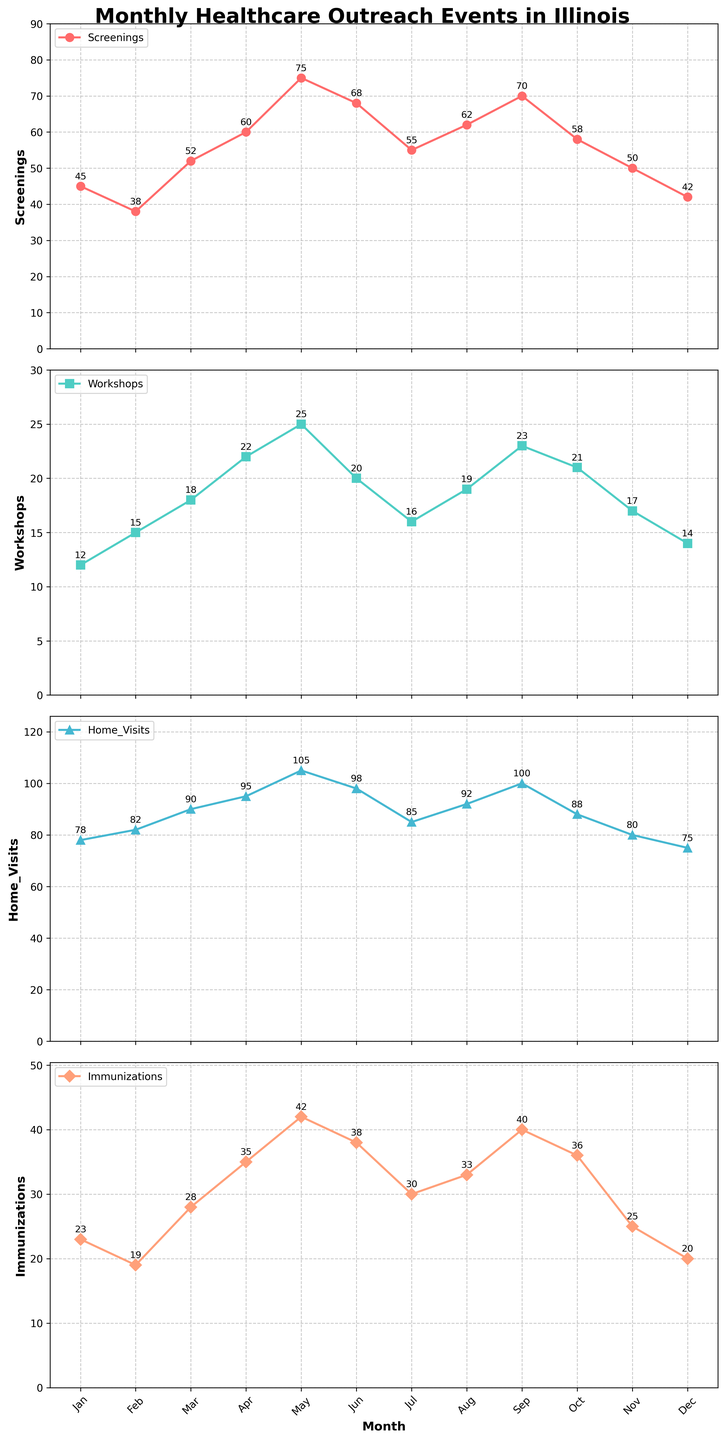What's the highest number of screenings conducted in a month? Check the "Screenings" subplot and identify the highest point on the y-axis, which is marked and labeled
Answer: 75 Which month had the lowest number of immunizations? Look at the "Immunizations" subplot, find the smallest y-axis value and correspond it to the month
Answer: February How does the number of home visits in April compare to that in October? Find April and October in the "Home_Visits" subplot and compare their y-axis values. April has 95, and October has 88
Answer: April is higher What's the total number of workshops conducted in the first half of the year? Sum the values of workshops for the first six months (Jan to Jun) from the "Workshops" subplot: 12 + 15 + 18 + 22 + 25 + 20 = 112
Answer: 112 In which month is the difference between screenings and home visits the largest? Calculate the difference between screenings and home visits for each month and find the maximum value. May:
Answer: 75 - 105 = -30 (absolute 30) How does the trend in immunizations change through the year? Look at the "Immunizations" subplot; generally, it rises from the start of the year, peaking around mid-year, then slightly decreases towards the end
Answer: Increasing then slightly decreasing Which activity had the smallest number of events in November? Compare the y-axis values for each subplot in November; workshops have the smallest value at 17
Answer: Workshops What is the average number of screenings conducted over the entire year? Sum the values of screenings across all months and divide by 12: (45 + 38 + 52 + 60 + 75 + 68 + 55 + 62 + 70 + 58 + 50 + 42) / 12 = 55.08
Answer: 55 In which month did screenings and immunizations have closest numbers? Compare values for screenings and immunizations for each month and find the month with the smallest difference. January: 45 and 23 (22 difference)
Answer: January Is the number of workshops in March greater than in July? Look at the "Workshops" subplot; March has 18, and July has 16
Answer: Yes 